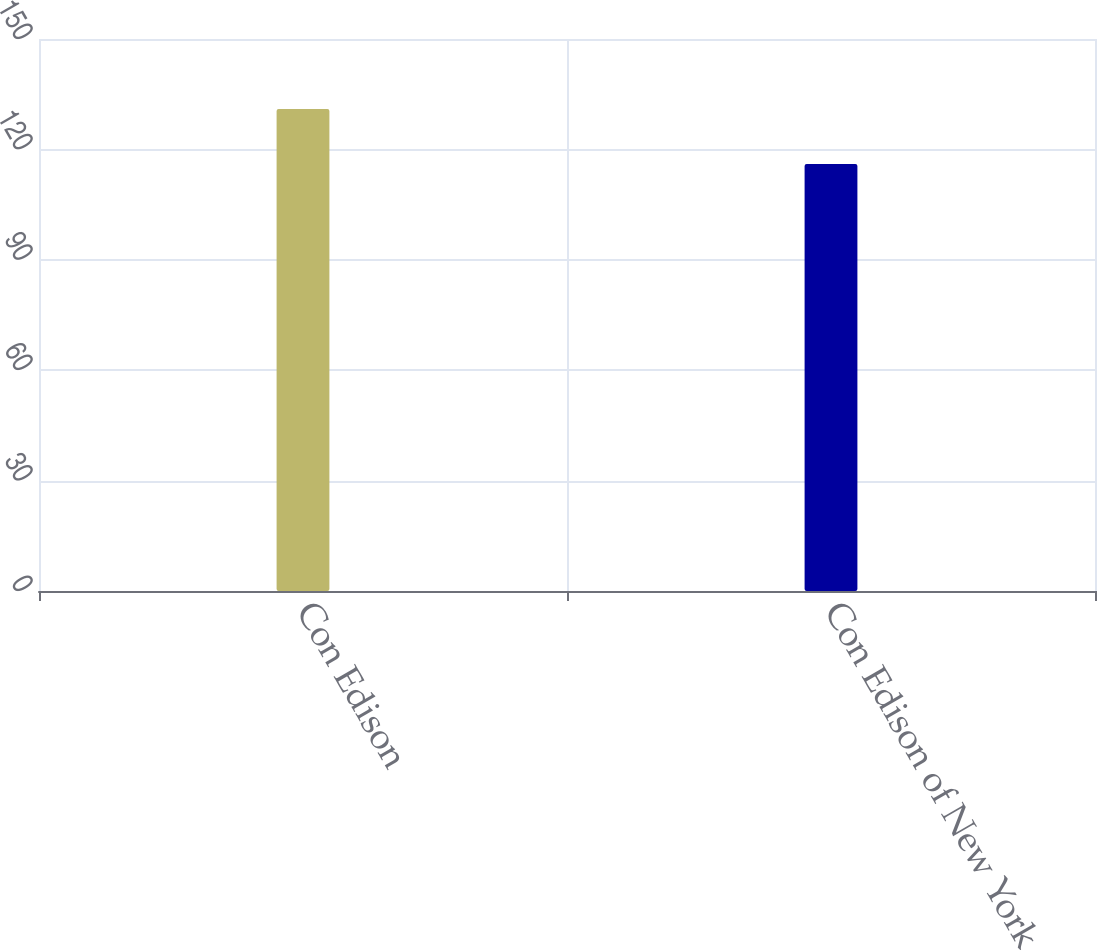<chart> <loc_0><loc_0><loc_500><loc_500><bar_chart><fcel>Con Edison<fcel>Con Edison of New York<nl><fcel>131<fcel>116<nl></chart> 